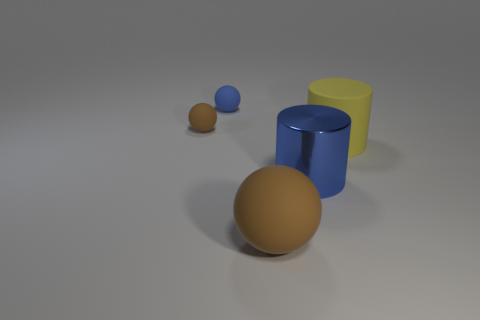Add 1 small purple balls. How many objects exist? 6 Subtract all blue rubber balls. How many balls are left? 2 Subtract 1 cylinders. How many cylinders are left? 1 Subtract all blue balls. How many balls are left? 2 Subtract all blue cubes. How many blue cylinders are left? 1 Subtract all big brown matte balls. Subtract all purple things. How many objects are left? 4 Add 3 big rubber cylinders. How many big rubber cylinders are left? 4 Add 2 tiny matte objects. How many tiny matte objects exist? 4 Subtract 0 yellow balls. How many objects are left? 5 Subtract all balls. How many objects are left? 2 